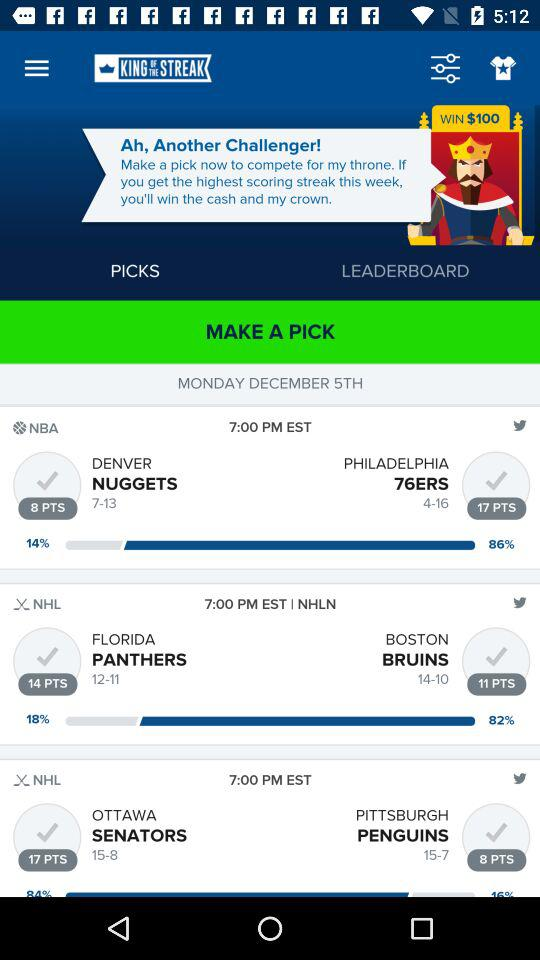How many points do the Nuggets have? The Nugget has 8 points. 